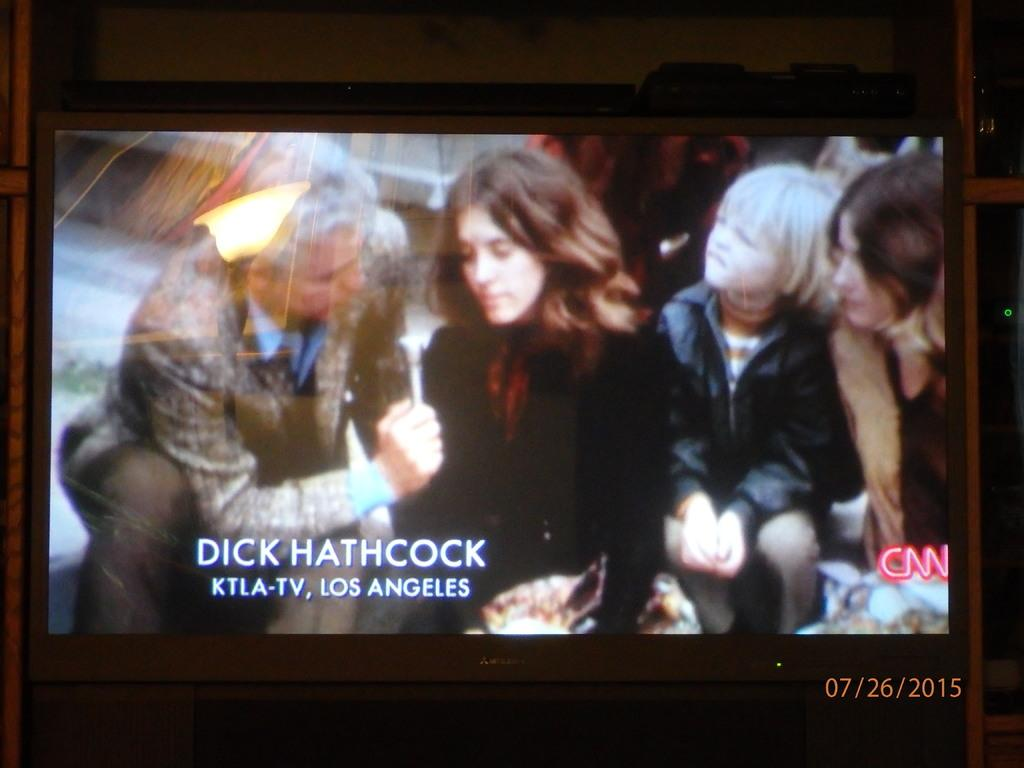<image>
Render a clear and concise summary of the photo. A picture of a TV interview with the name Dick Hathcock at the bottom left 